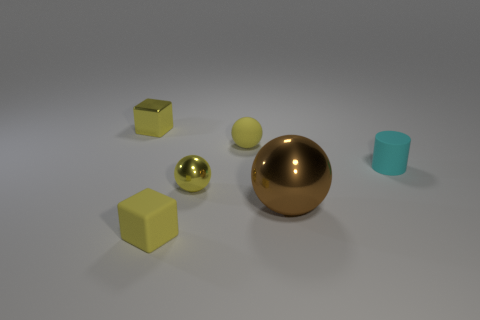Are there any other things that are the same size as the brown thing?
Provide a short and direct response. No. Are there any other things that are the same shape as the small cyan matte object?
Offer a terse response. No. How many tiny cylinders are made of the same material as the cyan object?
Give a very brief answer. 0. The other sphere that is made of the same material as the big brown ball is what color?
Offer a very short reply. Yellow. The yellow cube in front of the small metal object behind the tiny ball that is in front of the cyan rubber thing is made of what material?
Offer a very short reply. Rubber. Is the size of the yellow cube on the right side of the yellow metal cube the same as the large thing?
Keep it short and to the point. No. How many tiny objects are yellow rubber blocks or cyan cylinders?
Make the answer very short. 2. Are there any matte things that have the same color as the shiny block?
Offer a terse response. Yes. There is a metal object that is the same size as the yellow metal ball; what is its shape?
Your answer should be very brief. Cube. There is a small sphere behind the small cyan matte thing; is it the same color as the small shiny sphere?
Offer a very short reply. Yes. 